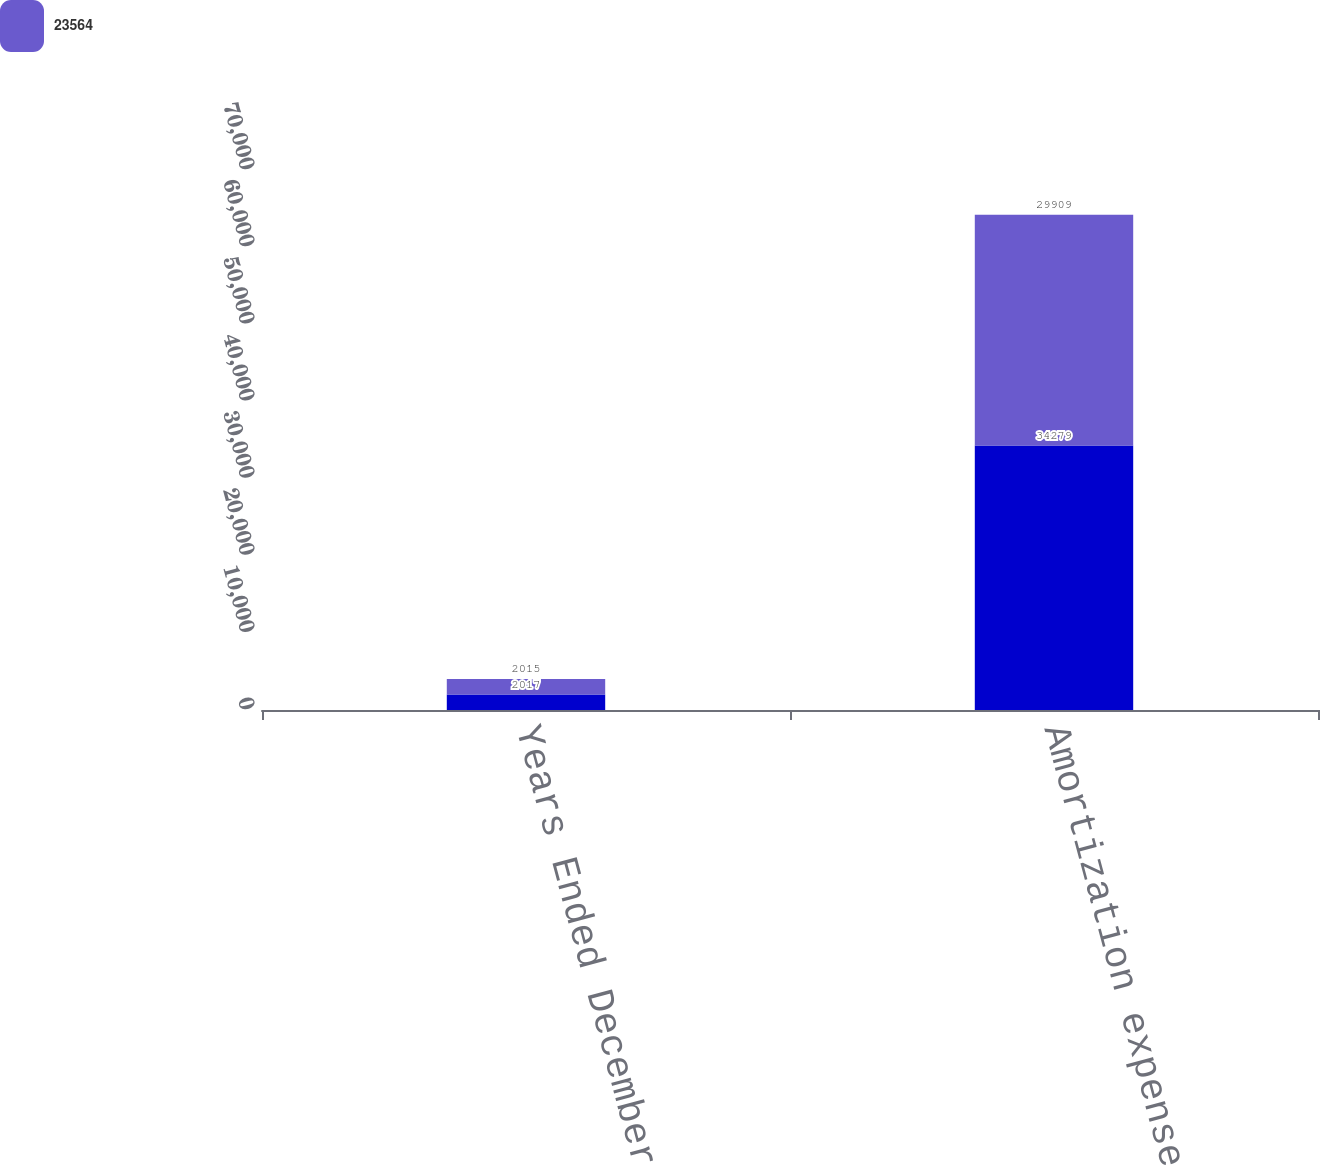Convert chart. <chart><loc_0><loc_0><loc_500><loc_500><stacked_bar_chart><ecel><fcel>Years Ended December 31<fcel>Amortization expense<nl><fcel>nan<fcel>2017<fcel>34279<nl><fcel>23564<fcel>2015<fcel>29909<nl></chart> 